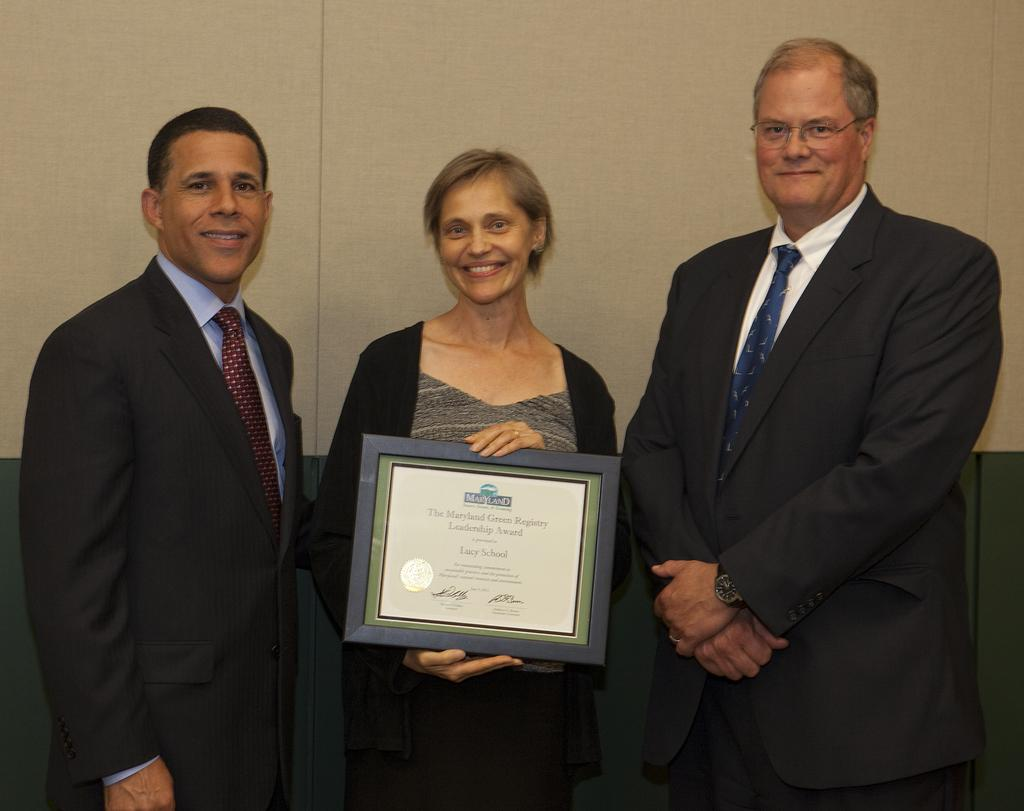How many people are in the image? There are people in the image, but the exact number is not specified. What are the people wearing? The people in the image are wearing clothes. What is the person in the middle of the image holding? The person in the middle of the image is holding a memorandum. What can be seen in the background of the image? There is a wall in the background of the image. What type of club does the person in the image use to hit the ball? There is no club or ball present in the image; it features people and a person holding a memorandum. What is the name of the son of the person in the image? There is no mention of a son or any personal information about the people in the image. 